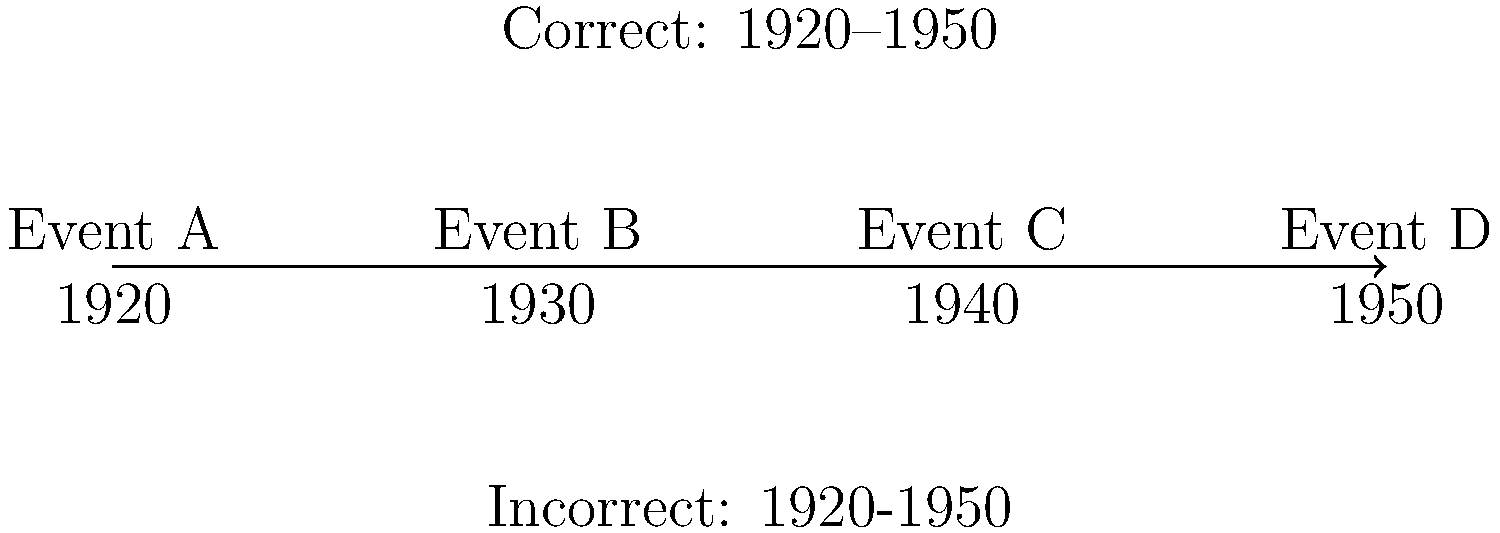In the timeline graphic above, which punctuation mark should be used to represent the span of years from 1920 to 1950, and why is it the most appropriate choice for this context? To determine the correct punctuation for the timeline, let's consider the options and their uses:

1. Hyphens (-): Used for compound words and to join numbers in ranges within sentences.
2. En dashes (–): Used for number ranges, especially in formal writing and when representing time spans.
3. Em dashes (—): Used for abrupt breaks in thought or to set off parenthetical information.

For this timeline graphic:

1. The span represents a range of years, which calls for either a hyphen or an en dash.
2. In professional and formal contexts, such as in publishing and editorial work, en dashes are preferred for number ranges.
3. The timeline is a graphic element, not in-line text, which further supports the use of an en dash for clarity.
4. Em dashes would be inappropriate here as they're not typically used for number ranges.

Therefore, the most appropriate punctuation mark for this timeline is the en dash (–). It clearly represents the span of years from 1920 to 1950 in a visually distinct and professionally accepted manner.
Answer: En dash (–) 